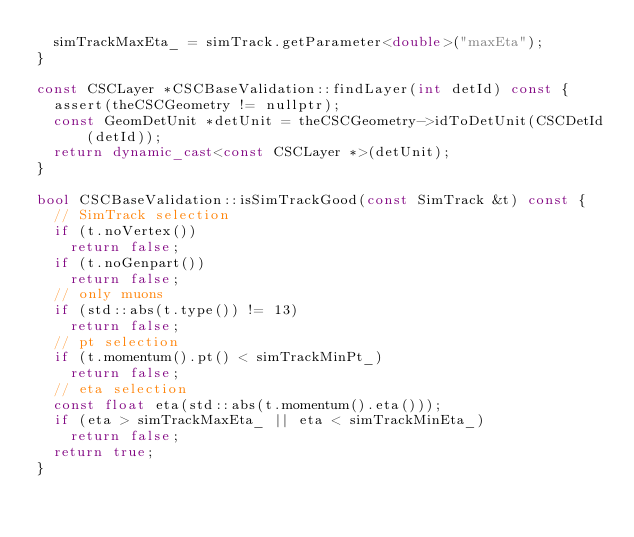Convert code to text. <code><loc_0><loc_0><loc_500><loc_500><_C++_>  simTrackMaxEta_ = simTrack.getParameter<double>("maxEta");
}

const CSCLayer *CSCBaseValidation::findLayer(int detId) const {
  assert(theCSCGeometry != nullptr);
  const GeomDetUnit *detUnit = theCSCGeometry->idToDetUnit(CSCDetId(detId));
  return dynamic_cast<const CSCLayer *>(detUnit);
}

bool CSCBaseValidation::isSimTrackGood(const SimTrack &t) const {
  // SimTrack selection
  if (t.noVertex())
    return false;
  if (t.noGenpart())
    return false;
  // only muons
  if (std::abs(t.type()) != 13)
    return false;
  // pt selection
  if (t.momentum().pt() < simTrackMinPt_)
    return false;
  // eta selection
  const float eta(std::abs(t.momentum().eta()));
  if (eta > simTrackMaxEta_ || eta < simTrackMinEta_)
    return false;
  return true;
}
</code> 